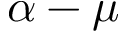Convert formula to latex. <formula><loc_0><loc_0><loc_500><loc_500>\alpha - \mu</formula> 